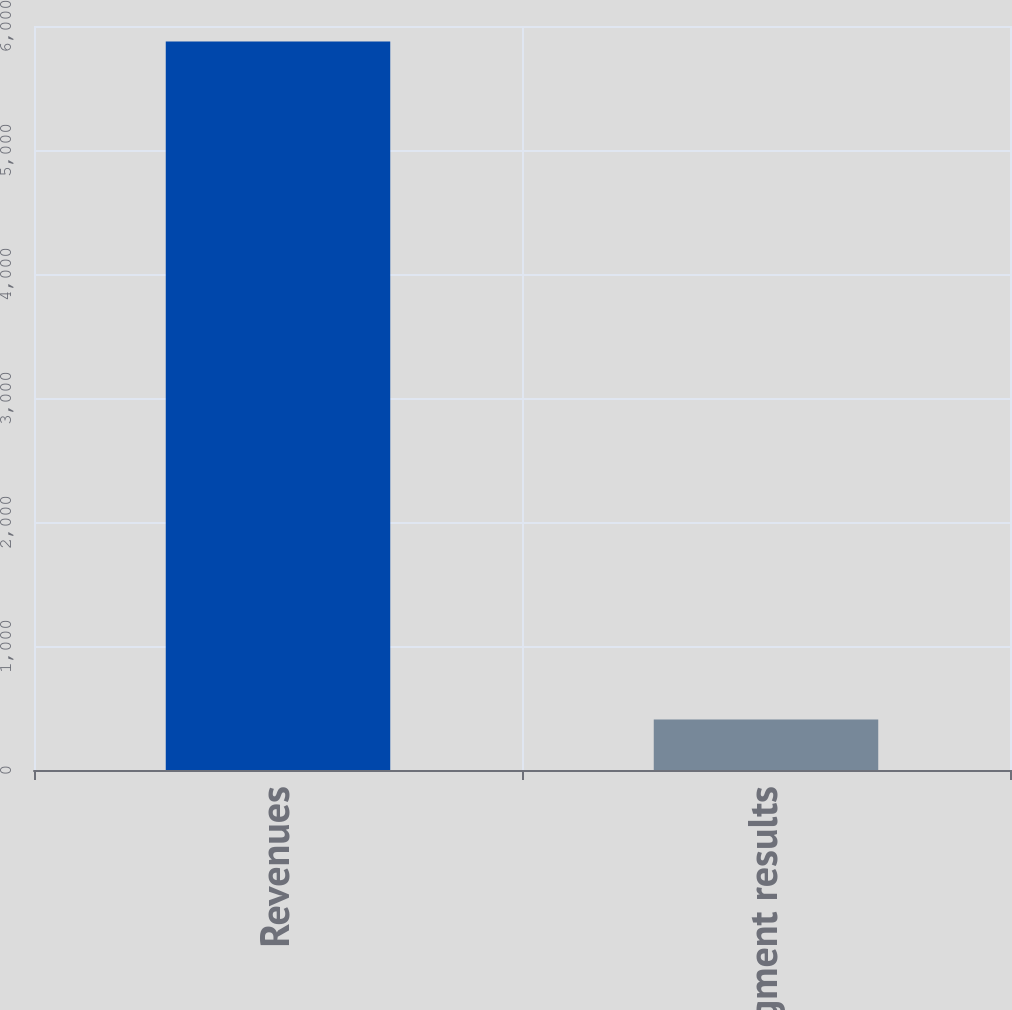<chart> <loc_0><loc_0><loc_500><loc_500><bar_chart><fcel>Revenues<fcel>Segment results<nl><fcel>5876<fcel>407<nl></chart> 